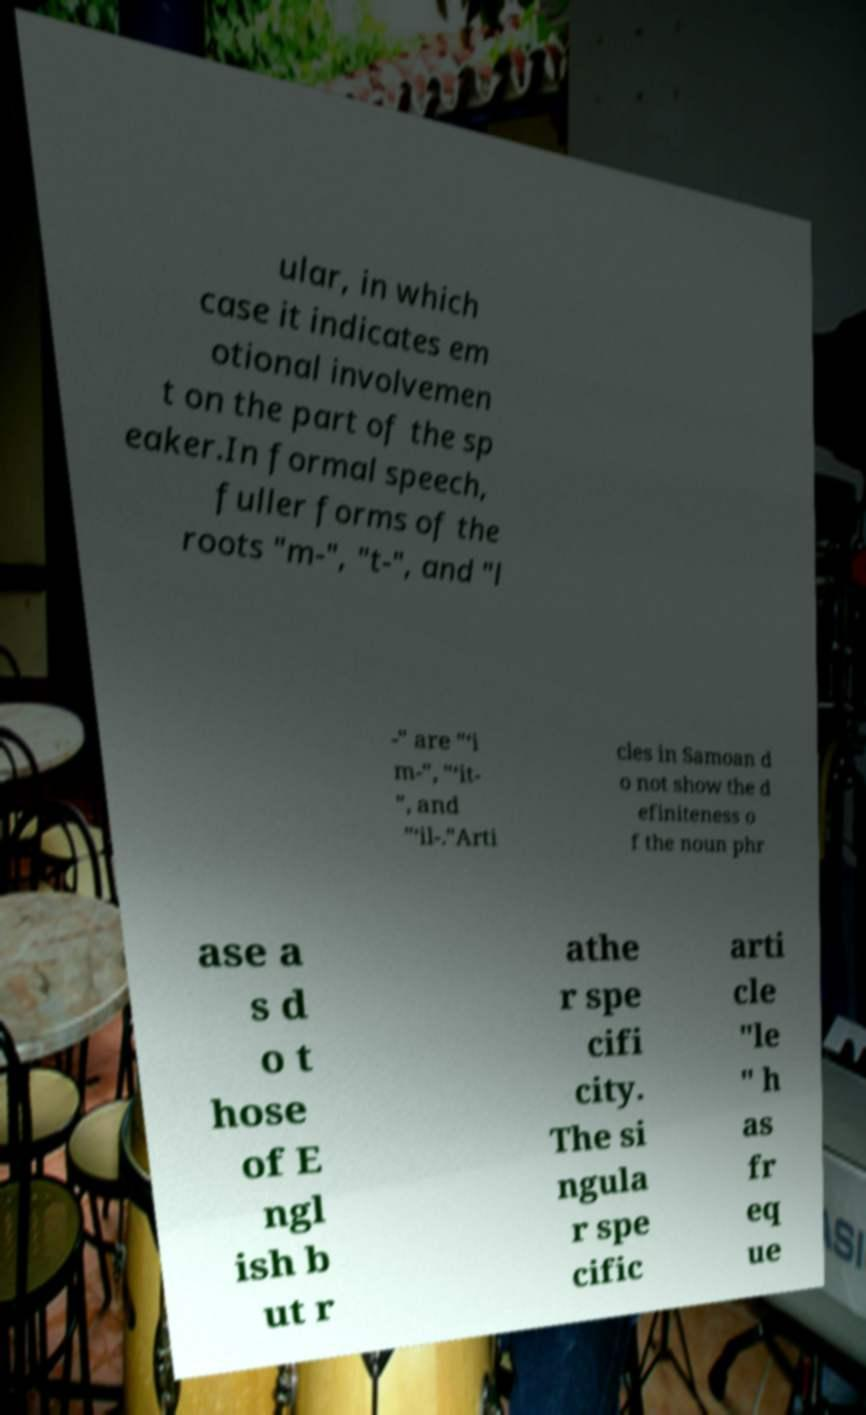Can you read and provide the text displayed in the image?This photo seems to have some interesting text. Can you extract and type it out for me? ular, in which case it indicates em otional involvemen t on the part of the sp eaker.In formal speech, fuller forms of the roots "m-", "t-", and "l -" are "‘i m-", "‘it- ", and "‘il-."Arti cles in Samoan d o not show the d efiniteness o f the noun phr ase a s d o t hose of E ngl ish b ut r athe r spe cifi city. The si ngula r spe cific arti cle "le " h as fr eq ue 